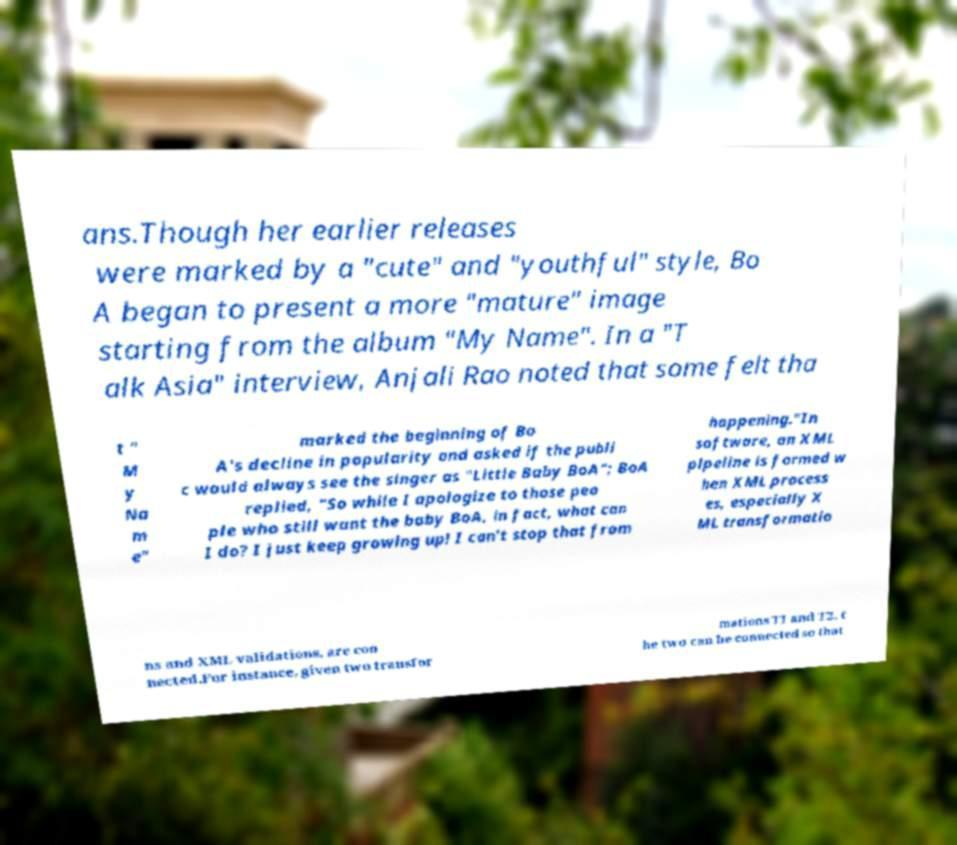Can you accurately transcribe the text from the provided image for me? ans.Though her earlier releases were marked by a "cute" and "youthful" style, Bo A began to present a more "mature" image starting from the album "My Name". In a "T alk Asia" interview, Anjali Rao noted that some felt tha t " M y Na m e" marked the beginning of Bo A's decline in popularity and asked if the publi c would always see the singer as "Little Baby BoA"; BoA replied, "So while I apologize to those peo ple who still want the baby BoA, in fact, what can I do? I just keep growing up! I can't stop that from happening."In software, an XML pipeline is formed w hen XML process es, especially X ML transformatio ns and XML validations, are con nected.For instance, given two transfor mations T1 and T2, t he two can be connected so that 